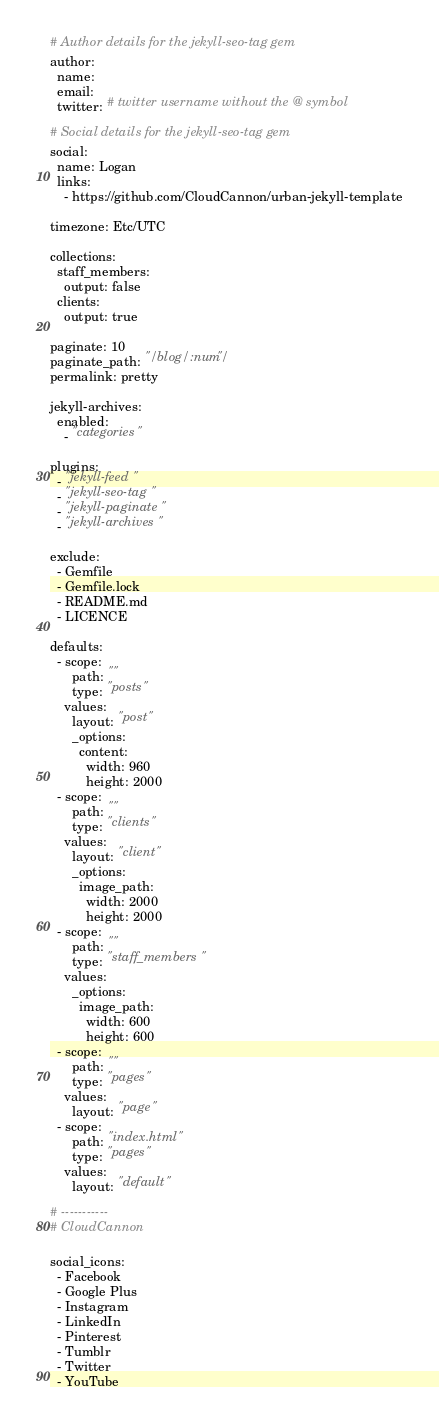<code> <loc_0><loc_0><loc_500><loc_500><_YAML_>
# Author details for the jekyll-seo-tag gem
author:
  name:
  email:
  twitter: # twitter username without the @ symbol

# Social details for the jekyll-seo-tag gem
social:
  name: Logan
  links:
    - https://github.com/CloudCannon/urban-jekyll-template

timezone: Etc/UTC

collections:
  staff_members:
    output: false
  clients:
    output: true

paginate: 10
paginate_path: "/blog/:num/"
permalink: pretty

jekyll-archives:
  enabled:
    - "categories"

plugins:
  - "jekyll-feed"
  - "jekyll-seo-tag"
  - "jekyll-paginate"
  - "jekyll-archives"

exclude:
  - Gemfile
  - Gemfile.lock
  - README.md
  - LICENCE

defaults:
  - scope:
      path: ""
      type: "posts"
    values:
      layout: "post"
      _options:
        content:
          width: 960
          height: 2000
  - scope:
      path: ""
      type: "clients"
    values:
      layout: "client"
      _options:
        image_path:
          width: 2000
          height: 2000
  - scope:
      path: ""
      type: "staff_members"
    values:
      _options:
        image_path:
          width: 600
          height: 600
  - scope:
      path: ""
      type: "pages"
    values:
      layout: "page"
  - scope:
      path: "index.html"
      type: "pages"
    values:
      layout: "default"

# -----------
# CloudCannon

social_icons:
  - Facebook
  - Google Plus
  - Instagram
  - LinkedIn
  - Pinterest
  - Tumblr
  - Twitter
  - YouTube

</code> 